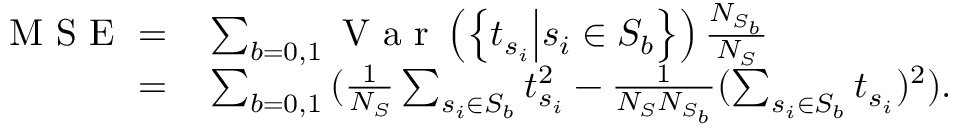<formula> <loc_0><loc_0><loc_500><loc_500>\begin{array} { r l } { M S E = } & \sum _ { b = 0 , 1 } { V a r \left ( \left \{ t _ { s _ { i } } | d l e | s _ { i } \in S _ { b } \right \} \right ) \frac { N _ { S _ { b } } } { N _ { S } } } } \\ { = } & \sum _ { b = 0 , 1 } { ( \frac { 1 } { N _ { S } } \sum _ { s _ { i } \in S _ { b } } t _ { s _ { i } } ^ { 2 } - \frac { 1 } { N _ { S } N _ { S _ { b } } } ( \sum _ { s _ { i } \in S _ { b } } t _ { s _ { i } } ) ^ { 2 } ) } . } \end{array}</formula> 